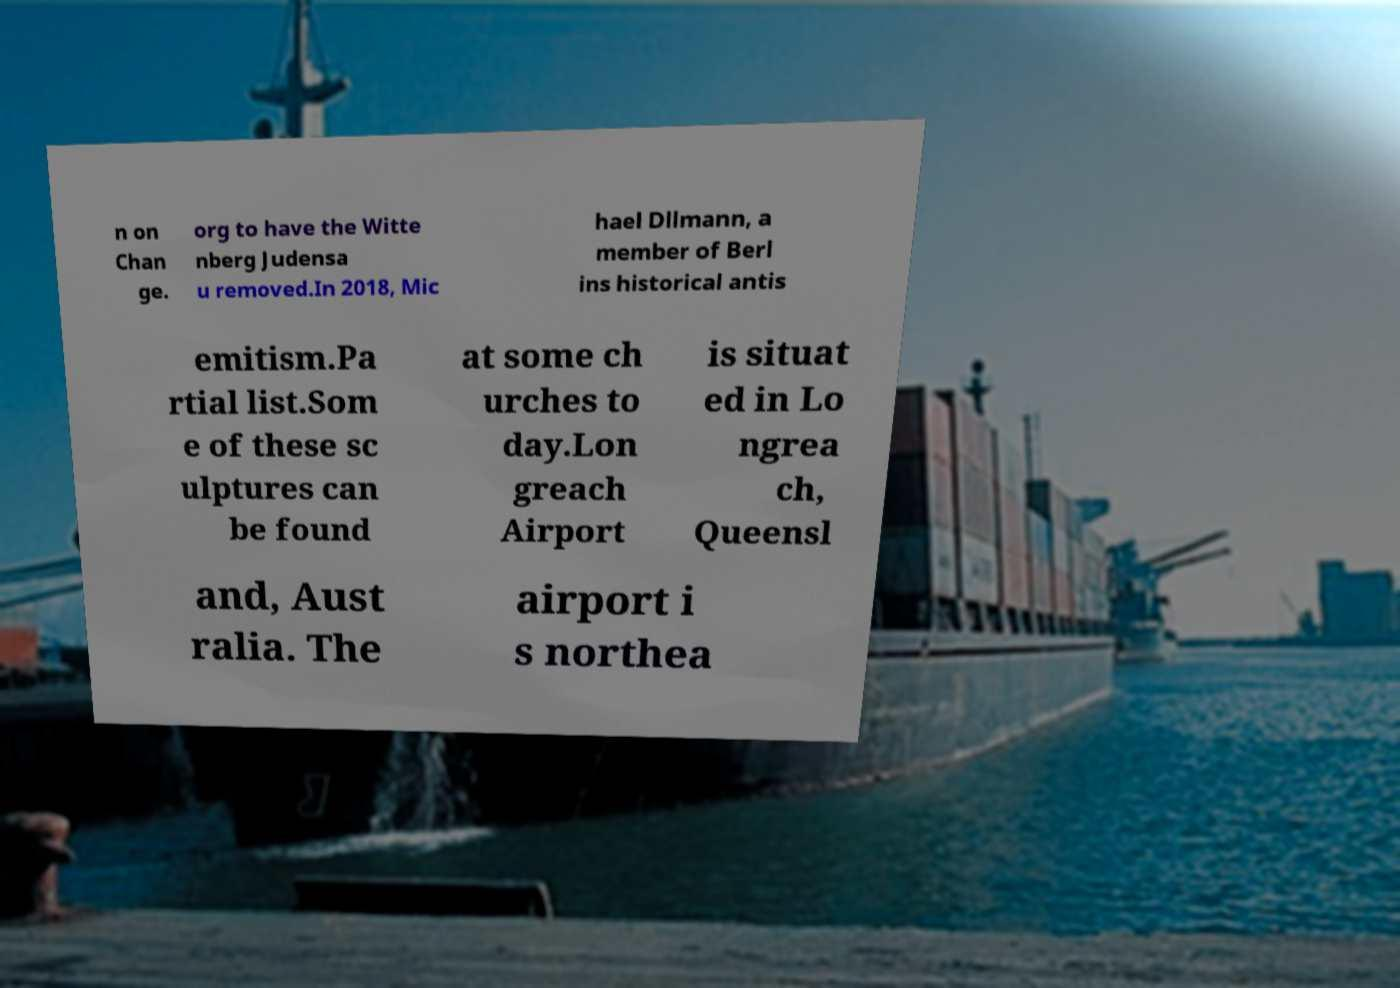I need the written content from this picture converted into text. Can you do that? n on Chan ge. org to have the Witte nberg Judensa u removed.In 2018, Mic hael Dllmann, a member of Berl ins historical antis emitism.Pa rtial list.Som e of these sc ulptures can be found at some ch urches to day.Lon greach Airport is situat ed in Lo ngrea ch, Queensl and, Aust ralia. The airport i s northea 